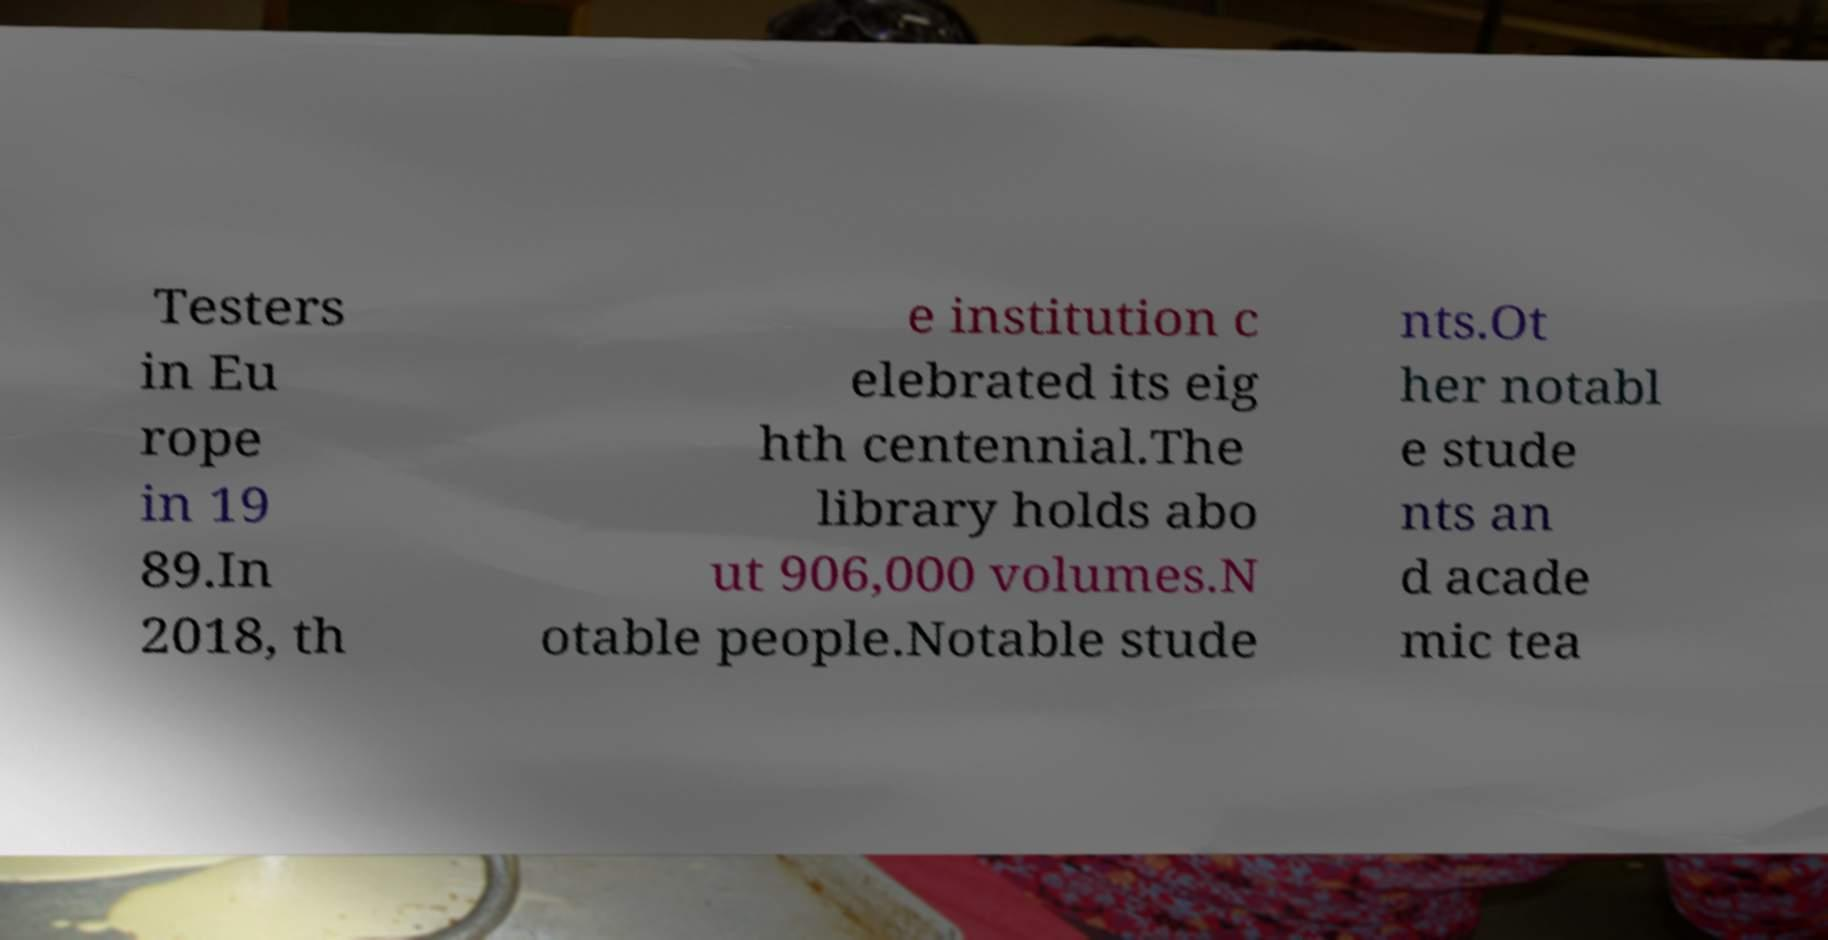I need the written content from this picture converted into text. Can you do that? Testers in Eu rope in 19 89.In 2018, th e institution c elebrated its eig hth centennial.The library holds abo ut 906,000 volumes.N otable people.Notable stude nts.Ot her notabl e stude nts an d acade mic tea 